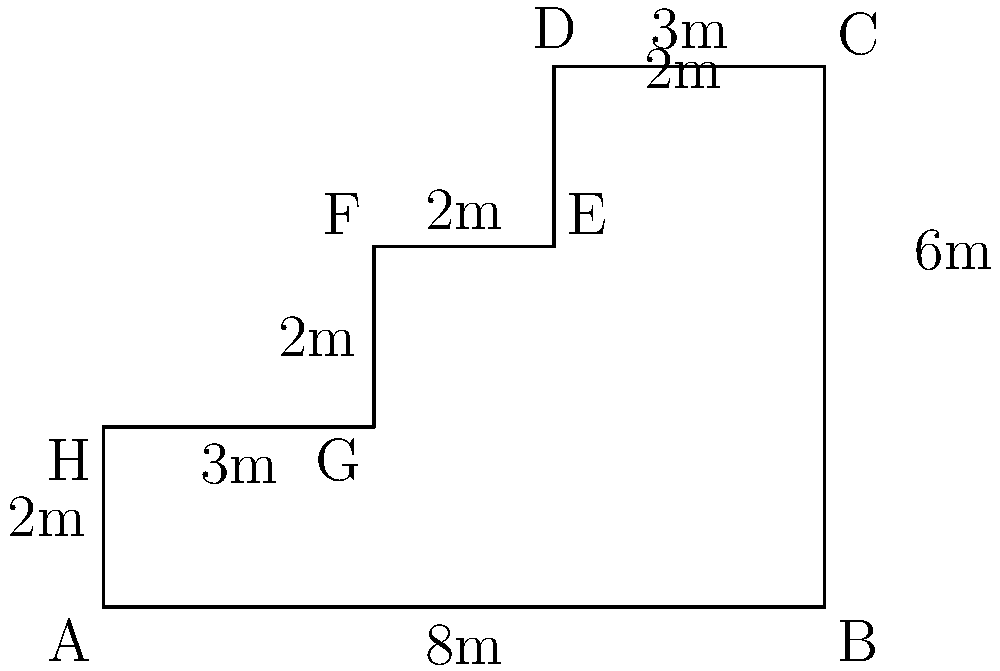You need to fence an irregularly shaped agricultural plot to protect your high-quality export crops. The plot's shape is shown in the diagram above, with measurements in meters. Calculate the total length of fencing required to enclose the entire plot. To find the perimeter of the irregularly shaped plot, we need to sum up the lengths of all sides:

1. Side AB: 8m
2. Side BC: 6m
3. Side CD: 3m
4. Side DE: 2m
5. Side EF: 2m
6. Side FG: 2m
7. Side GH: 3m
8. Side HA: 2m

Now, let's add all these lengths:

$$8 + 6 + 3 + 2 + 2 + 2 + 3 + 2 = 28$$

Therefore, the total length of fencing required is 28 meters.
Answer: 28 meters 